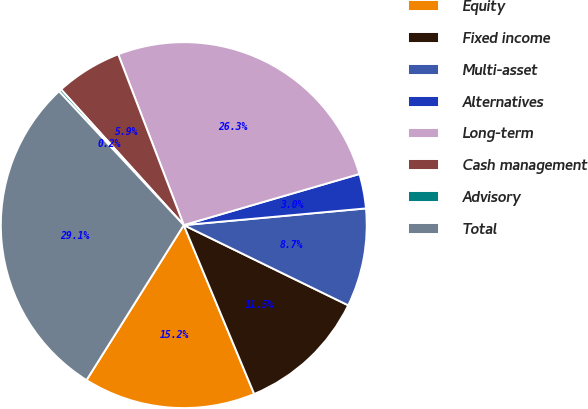<chart> <loc_0><loc_0><loc_500><loc_500><pie_chart><fcel>Equity<fcel>Fixed income<fcel>Multi-asset<fcel>Alternatives<fcel>Long-term<fcel>Cash management<fcel>Advisory<fcel>Total<nl><fcel>15.21%<fcel>11.49%<fcel>8.68%<fcel>3.05%<fcel>26.33%<fcel>5.87%<fcel>0.24%<fcel>29.14%<nl></chart> 